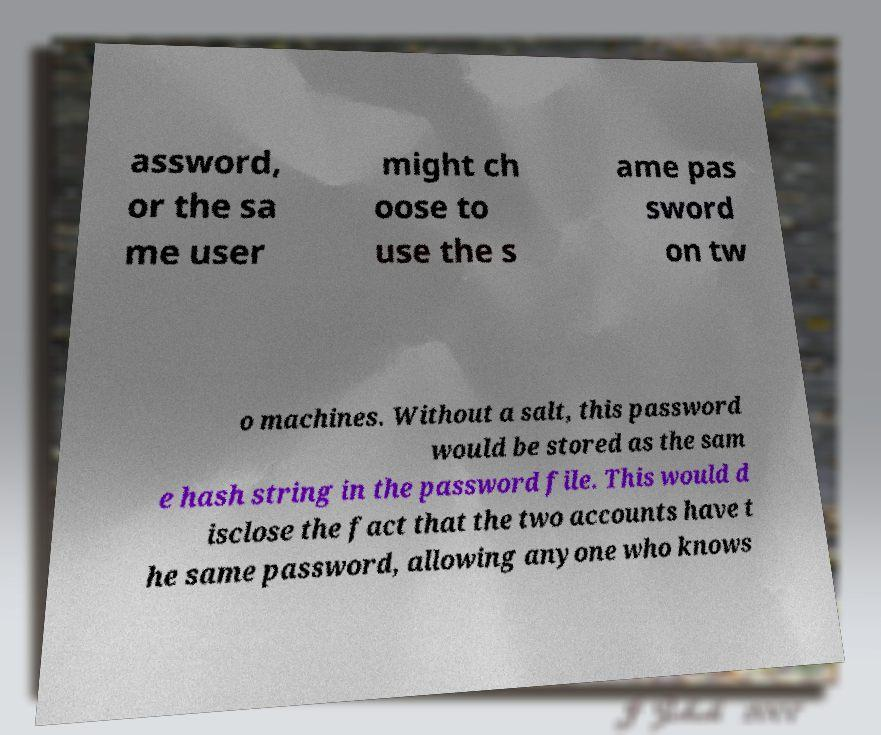Please identify and transcribe the text found in this image. assword, or the sa me user might ch oose to use the s ame pas sword on tw o machines. Without a salt, this password would be stored as the sam e hash string in the password file. This would d isclose the fact that the two accounts have t he same password, allowing anyone who knows 